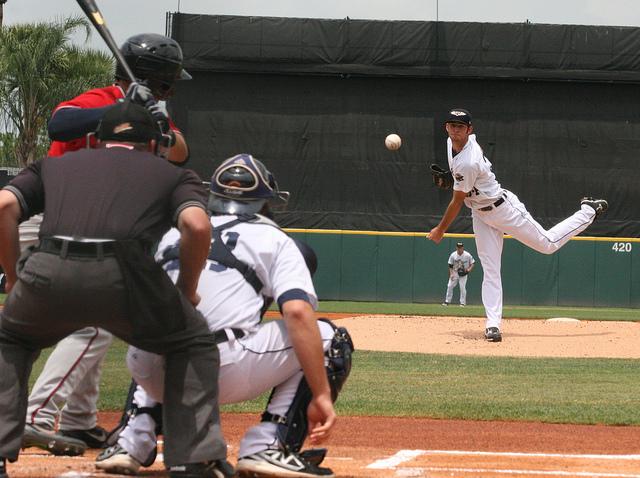What is this sport?
Be succinct. Baseball. What is the pitcher's throwing handedness?
Give a very brief answer. Left. What color is the pitcher's uniform?
Be succinct. White. 